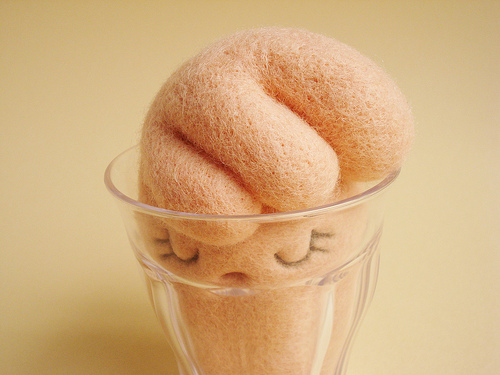<image>
Can you confirm if the icecream is on the cup? No. The icecream is not positioned on the cup. They may be near each other, but the icecream is not supported by or resting on top of the cup. Is there a bunny in the glass? Yes. The bunny is contained within or inside the glass, showing a containment relationship. 